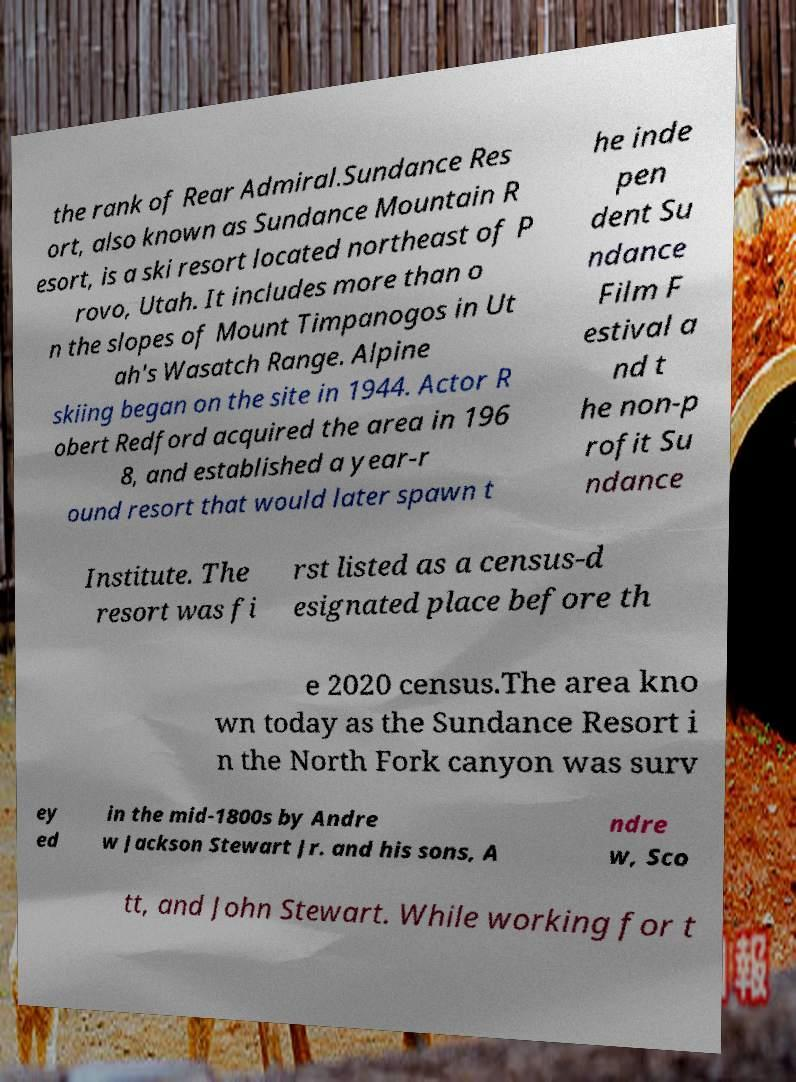Can you read and provide the text displayed in the image?This photo seems to have some interesting text. Can you extract and type it out for me? the rank of Rear Admiral.Sundance Res ort, also known as Sundance Mountain R esort, is a ski resort located northeast of P rovo, Utah. It includes more than o n the slopes of Mount Timpanogos in Ut ah's Wasatch Range. Alpine skiing began on the site in 1944. Actor R obert Redford acquired the area in 196 8, and established a year-r ound resort that would later spawn t he inde pen dent Su ndance Film F estival a nd t he non-p rofit Su ndance Institute. The resort was fi rst listed as a census-d esignated place before th e 2020 census.The area kno wn today as the Sundance Resort i n the North Fork canyon was surv ey ed in the mid-1800s by Andre w Jackson Stewart Jr. and his sons, A ndre w, Sco tt, and John Stewart. While working for t 